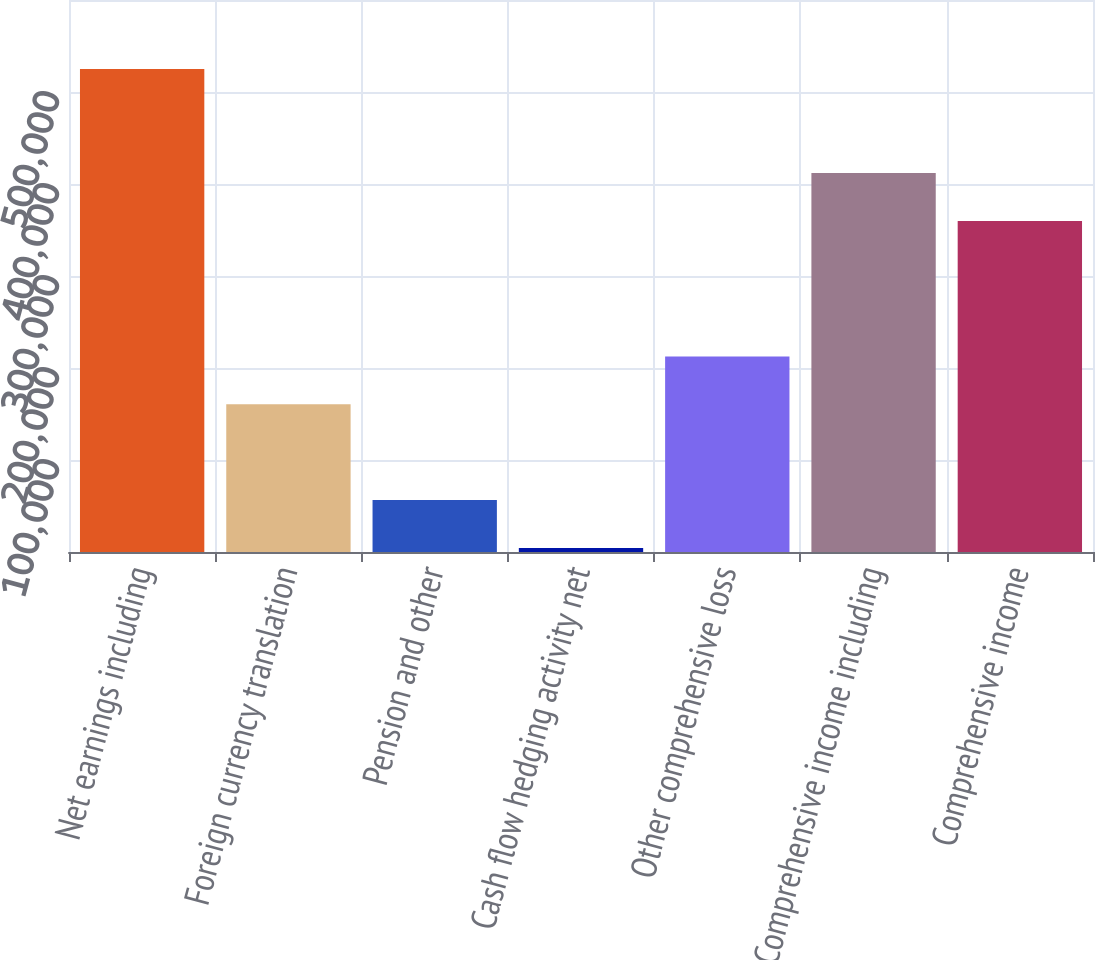Convert chart. <chart><loc_0><loc_0><loc_500><loc_500><bar_chart><fcel>Net earnings including<fcel>Foreign currency translation<fcel>Pension and other<fcel>Cash flow hedging activity net<fcel>Other comprehensive loss<fcel>Comprehensive income including<fcel>Comprehensive income<nl><fcel>524885<fcel>160543<fcel>56444.9<fcel>4396<fcel>212592<fcel>411944<fcel>359895<nl></chart> 